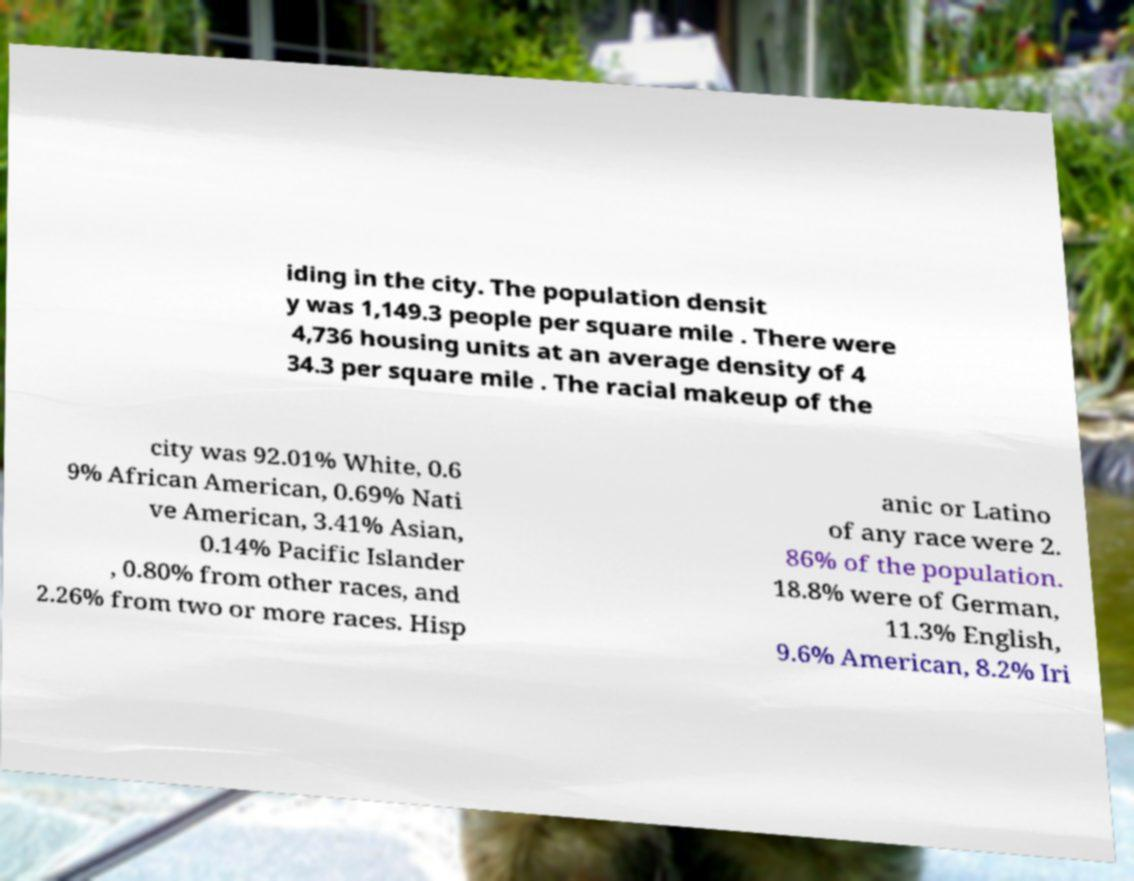Can you read and provide the text displayed in the image?This photo seems to have some interesting text. Can you extract and type it out for me? iding in the city. The population densit y was 1,149.3 people per square mile . There were 4,736 housing units at an average density of 4 34.3 per square mile . The racial makeup of the city was 92.01% White, 0.6 9% African American, 0.69% Nati ve American, 3.41% Asian, 0.14% Pacific Islander , 0.80% from other races, and 2.26% from two or more races. Hisp anic or Latino of any race were 2. 86% of the population. 18.8% were of German, 11.3% English, 9.6% American, 8.2% Iri 